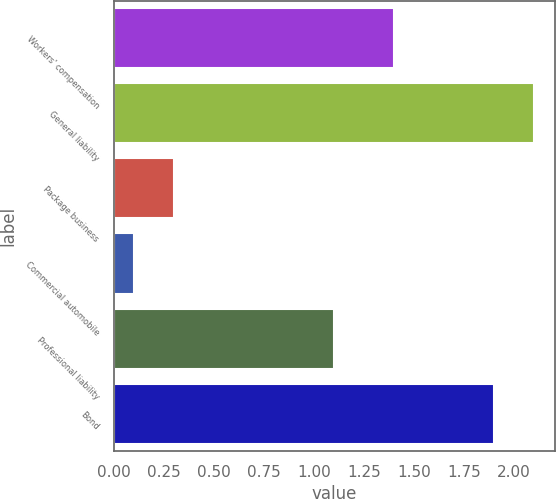Convert chart to OTSL. <chart><loc_0><loc_0><loc_500><loc_500><bar_chart><fcel>Workers' compensation<fcel>General liability<fcel>Package business<fcel>Commercial automobile<fcel>Professional liability<fcel>Bond<nl><fcel>1.4<fcel>2.1<fcel>0.3<fcel>0.1<fcel>1.1<fcel>1.9<nl></chart> 